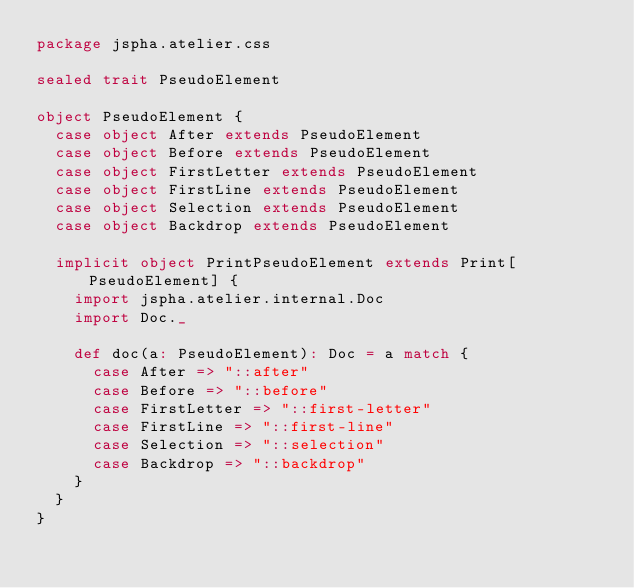Convert code to text. <code><loc_0><loc_0><loc_500><loc_500><_Scala_>package jspha.atelier.css

sealed trait PseudoElement

object PseudoElement {
  case object After extends PseudoElement
  case object Before extends PseudoElement
  case object FirstLetter extends PseudoElement
  case object FirstLine extends PseudoElement
  case object Selection extends PseudoElement
  case object Backdrop extends PseudoElement

  implicit object PrintPseudoElement extends Print[PseudoElement] {
    import jspha.atelier.internal.Doc
    import Doc._

    def doc(a: PseudoElement): Doc = a match {
      case After => "::after"
      case Before => "::before"
      case FirstLetter => "::first-letter"
      case FirstLine => "::first-line"
      case Selection => "::selection"
      case Backdrop => "::backdrop"
    }
  }
}


</code> 